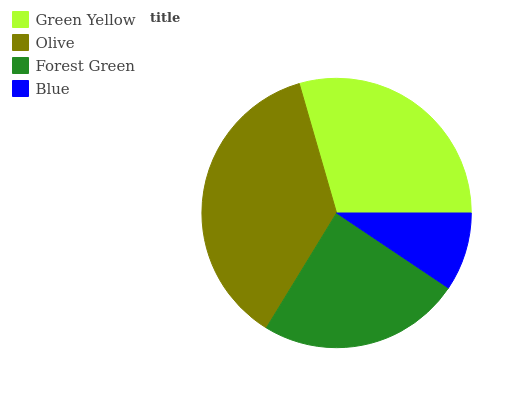Is Blue the minimum?
Answer yes or no. Yes. Is Olive the maximum?
Answer yes or no. Yes. Is Forest Green the minimum?
Answer yes or no. No. Is Forest Green the maximum?
Answer yes or no. No. Is Olive greater than Forest Green?
Answer yes or no. Yes. Is Forest Green less than Olive?
Answer yes or no. Yes. Is Forest Green greater than Olive?
Answer yes or no. No. Is Olive less than Forest Green?
Answer yes or no. No. Is Green Yellow the high median?
Answer yes or no. Yes. Is Forest Green the low median?
Answer yes or no. Yes. Is Blue the high median?
Answer yes or no. No. Is Olive the low median?
Answer yes or no. No. 